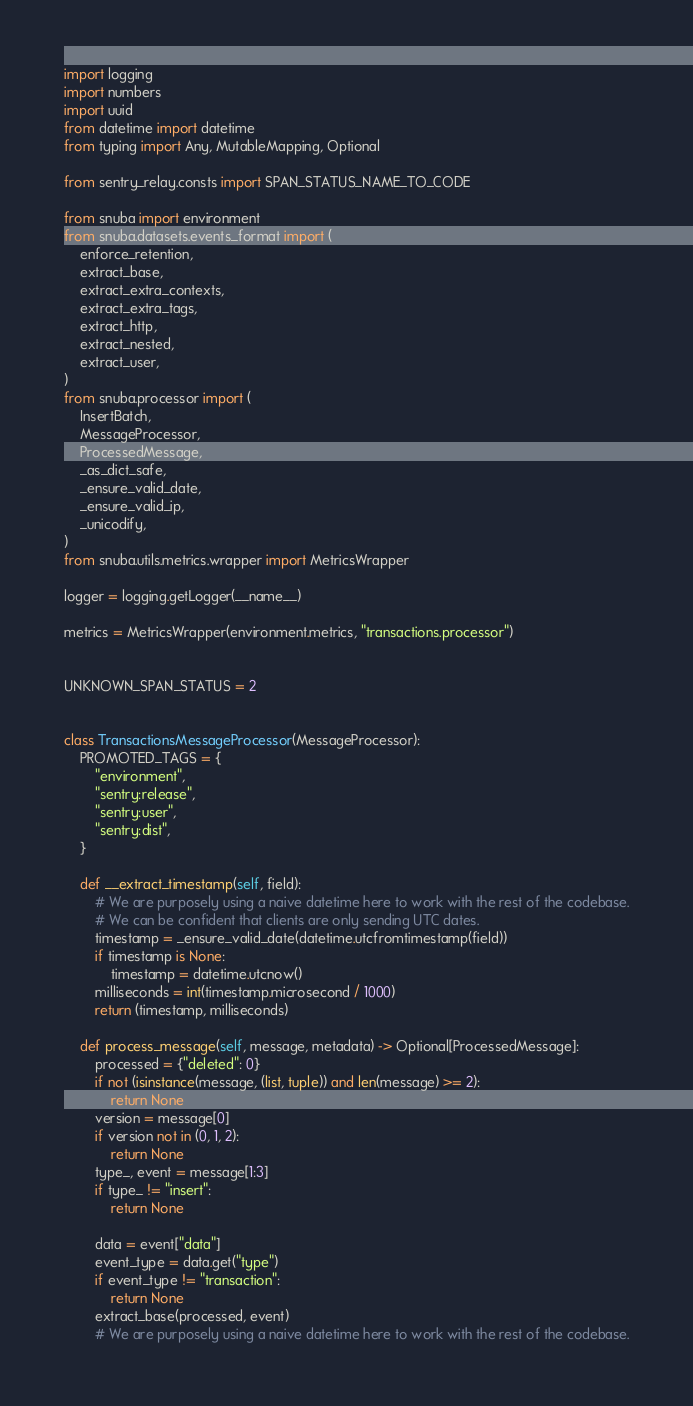<code> <loc_0><loc_0><loc_500><loc_500><_Python_>import logging
import numbers
import uuid
from datetime import datetime
from typing import Any, MutableMapping, Optional

from sentry_relay.consts import SPAN_STATUS_NAME_TO_CODE

from snuba import environment
from snuba.datasets.events_format import (
    enforce_retention,
    extract_base,
    extract_extra_contexts,
    extract_extra_tags,
    extract_http,
    extract_nested,
    extract_user,
)
from snuba.processor import (
    InsertBatch,
    MessageProcessor,
    ProcessedMessage,
    _as_dict_safe,
    _ensure_valid_date,
    _ensure_valid_ip,
    _unicodify,
)
from snuba.utils.metrics.wrapper import MetricsWrapper

logger = logging.getLogger(__name__)

metrics = MetricsWrapper(environment.metrics, "transactions.processor")


UNKNOWN_SPAN_STATUS = 2


class TransactionsMessageProcessor(MessageProcessor):
    PROMOTED_TAGS = {
        "environment",
        "sentry:release",
        "sentry:user",
        "sentry:dist",
    }

    def __extract_timestamp(self, field):
        # We are purposely using a naive datetime here to work with the rest of the codebase.
        # We can be confident that clients are only sending UTC dates.
        timestamp = _ensure_valid_date(datetime.utcfromtimestamp(field))
        if timestamp is None:
            timestamp = datetime.utcnow()
        milliseconds = int(timestamp.microsecond / 1000)
        return (timestamp, milliseconds)

    def process_message(self, message, metadata) -> Optional[ProcessedMessage]:
        processed = {"deleted": 0}
        if not (isinstance(message, (list, tuple)) and len(message) >= 2):
            return None
        version = message[0]
        if version not in (0, 1, 2):
            return None
        type_, event = message[1:3]
        if type_ != "insert":
            return None

        data = event["data"]
        event_type = data.get("type")
        if event_type != "transaction":
            return None
        extract_base(processed, event)
        # We are purposely using a naive datetime here to work with the rest of the codebase.</code> 